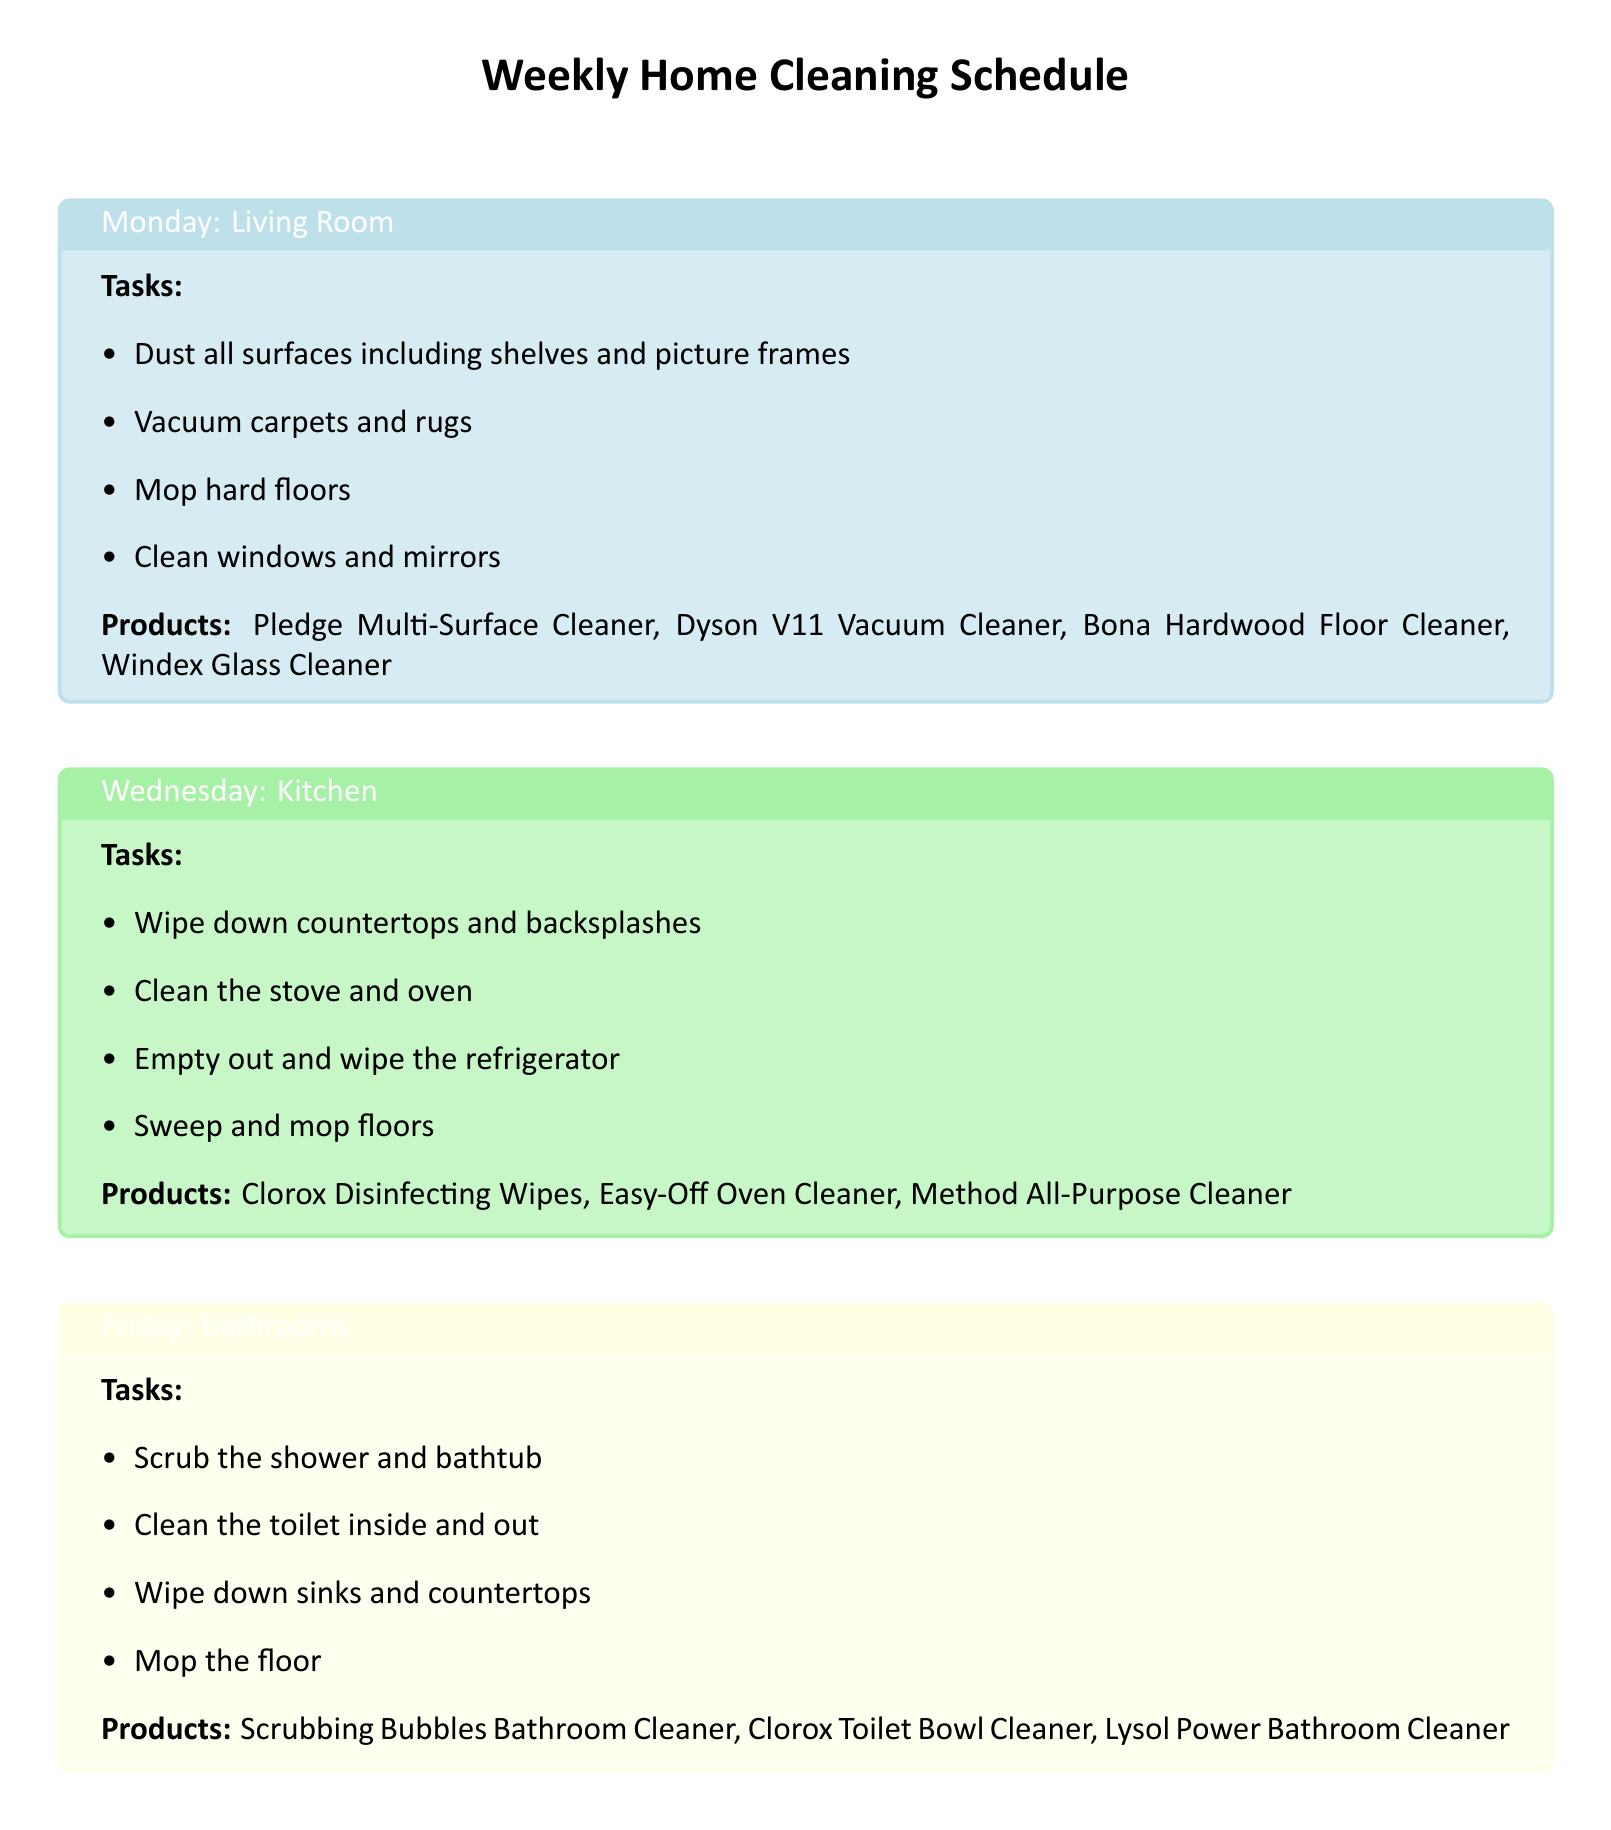What tasks are performed on Monday? The tasks listed for Monday are specific cleaning activities carried out in the Living Room.
Answer: Dust all surfaces including shelves and picture frames, Vacuum carpets and rugs, Mop hard floors, Clean windows and mirrors Which product is used for mopping hard floors? This question asks for the cleaning product designated for use on hard floors specifically mentioned in the Monday section.
Answer: Bona Hardwood Floor Cleaner How often are bed linens changed? The document specifies a cleaning schedule where bed linens are changed weekly on Sundays.
Answer: Weekly What area is scheduled for cleaning on Wednesday? The document outlines tasks assigned to specific days, and this question targets the location specified for Wednesday.
Answer: Kitchen How many cleaning products are listed for Sunday? This question inquires about the number of products mentioned specifically for Sunday tasks.
Answer: Three What task is common between the Living Room and Bedrooms? This requires reasoning about tasks that are performed in both areas as listed in the document.
Answer: Dust all surfaces What is the primary task for Fridays in the document? This question focuses on identifying the main cleaning focus mentioned for Fridays.
Answer: Bathrooms Which vacuum cleaner is mentioned in the Bedrooms section? This question seeks to identify the specific vacuum cleaner product mentioned under the Sunday cleaning tasks.
Answer: Shark Navigator Vacuum Cleaner What color is used for the Kitchen section in the document? The question asks for the color coding used visually in the document for the Kitchen section.
Answer: Pastel green 